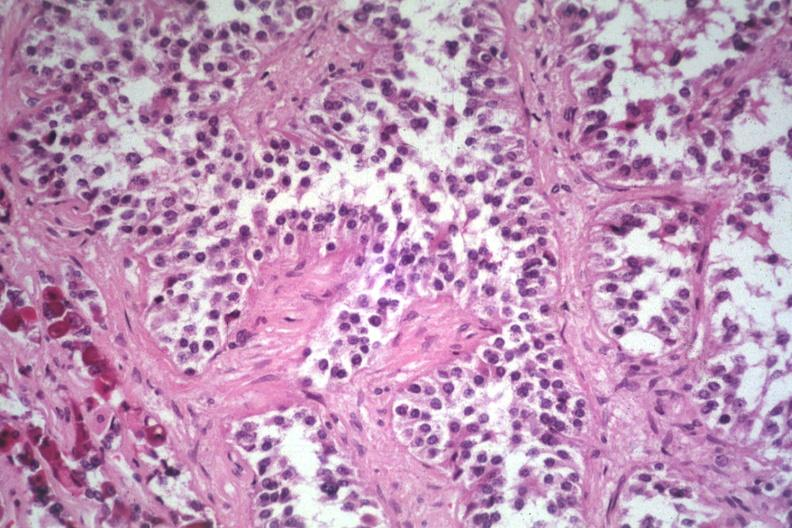s hemorrhage in newborn present?
Answer the question using a single word or phrase. No 